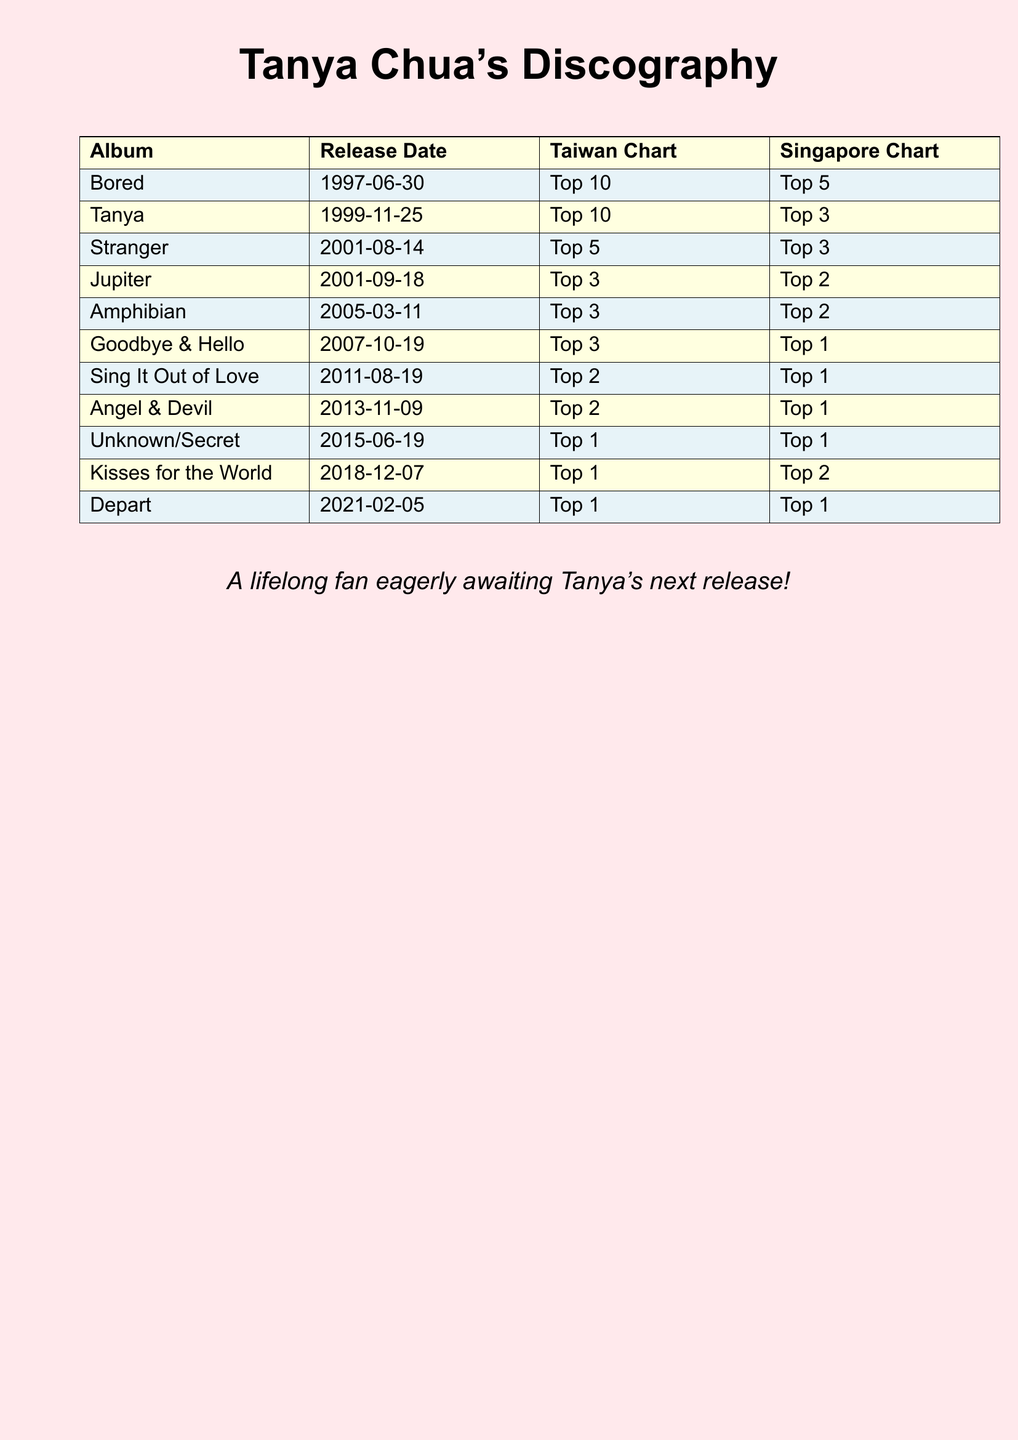What is the first album released by Tanya Chua? The first album in the list is "Bored," released on 1997-06-30.
Answer: Bored When was the album "Goodbye & Hello" released? The release date for "Goodbye & Hello" is given as 2007-10-19.
Answer: 2007-10-19 Which album reached the Top 1 in both Taiwan and Singapore? The album "Unknown/Secret" achieved Top 1 status on both charts.
Answer: Unknown/Secret How many albums did Tanya Chua release by 2015? By 2015, according to the list, there are 9 albums included.
Answer: 9 What is the highest position achieved by the album "Stranger" on the Taiwan Chart? The highest position for "Stranger" on the Taiwan Chart is Top 5.
Answer: Top 5 Which album was released immediately after "Jupiter"? "Amphibian" was released after "Jupiter."
Answer: Amphibian What position did "Depart" achieve on the Singapore Chart? The album "Depart" achieved Top 1 on the Singapore Chart.
Answer: Top 1 How many albums have been released since 2010? From 2010, three albums have been released: "Sing It Out of Love," "Angel & Devil," and "Unknown/Secret."
Answer: 3 Which album has the latest release date in the list? "Depart" is the last album listed with a release date of 2021-02-05.
Answer: Depart 